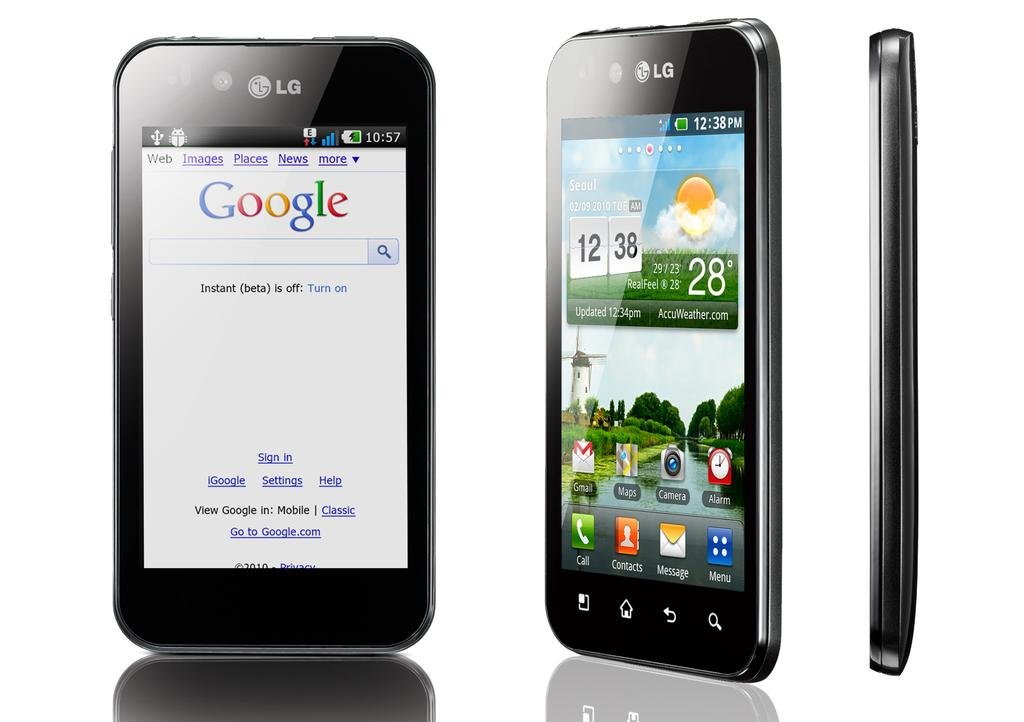What is the main subject of the image? The main subject of the image is a mobile phone. How many different angles of the mobile phone are shown in the image? There are three different angles of the mobile phone in the image. Are the mobile phones in each angle the same or different? The mobile phone is the same in each angle. Who is the owner of the gun in the image? There is no gun present in the image. What invention is being showcased in the image? The image does not showcase any specific invention; it simply displays a mobile phone from three different angles. 